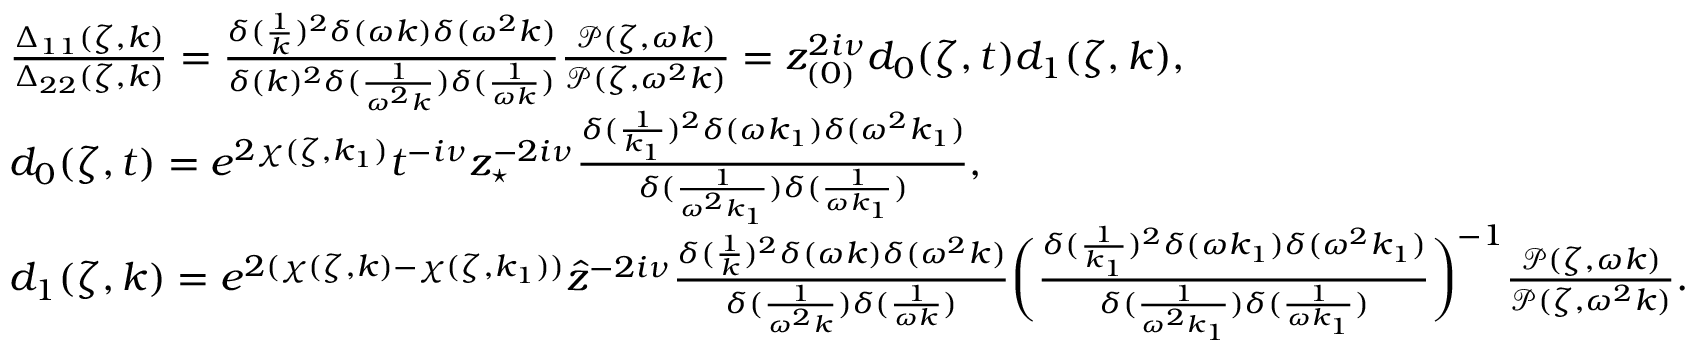<formula> <loc_0><loc_0><loc_500><loc_500>\begin{array} { r l } & { \frac { \Delta _ { 1 1 } ( \zeta , k ) } { \Delta _ { 2 2 } ( \zeta , k ) } = \frac { \delta ( \frac { 1 } { k } ) ^ { 2 } \delta ( \omega k ) \delta ( \omega ^ { 2 } k ) } { \delta ( k ) ^ { 2 } \delta ( \frac { 1 } { \omega ^ { 2 } k } ) \delta ( \frac { 1 } { \omega k } ) } \frac { \mathcal { P } ( \zeta , \omega k ) } { \mathcal { P } ( \zeta , \omega ^ { 2 } k ) } = z _ { ( 0 ) } ^ { 2 i \nu } d _ { 0 } ( \zeta , t ) d _ { 1 } ( \zeta , k ) , } \\ & { d _ { 0 } ( \zeta , t ) = e ^ { 2 \chi ( \zeta , k _ { 1 } ) } t ^ { - i \nu } z _ { ^ { * } } ^ { - 2 i \nu } \frac { \delta ( \frac { 1 } { k _ { 1 } } ) ^ { 2 } \delta ( \omega k _ { 1 } ) \delta ( \omega ^ { 2 } k _ { 1 } ) } { \delta ( \frac { 1 } { \omega ^ { 2 } k _ { 1 } } ) \delta ( \frac { 1 } { \omega k _ { 1 } } ) } , } \\ & { d _ { 1 } ( \zeta , k ) = e ^ { 2 ( \chi ( \zeta , k ) - \chi ( \zeta , k _ { 1 } ) ) } \hat { z } ^ { - 2 i \nu } \frac { \delta ( \frac { 1 } { k } ) ^ { 2 } \delta ( \omega k ) \delta ( \omega ^ { 2 } k ) } { \delta ( \frac { 1 } { \omega ^ { 2 } k } ) \delta ( \frac { 1 } { \omega k } ) } \left ( \frac { \delta ( \frac { 1 } { k _ { 1 } } ) ^ { 2 } \delta ( \omega k _ { 1 } ) \delta ( \omega ^ { 2 } k _ { 1 } ) } { \delta ( \frac { 1 } { \omega ^ { 2 } k _ { 1 } } ) \delta ( \frac { 1 } { \omega k _ { 1 } } ) } \right ) ^ { - 1 } \frac { \mathcal { P } ( \zeta , \omega k ) } { \mathcal { P } ( \zeta , \omega ^ { 2 } k ) } . } \end{array}</formula> 